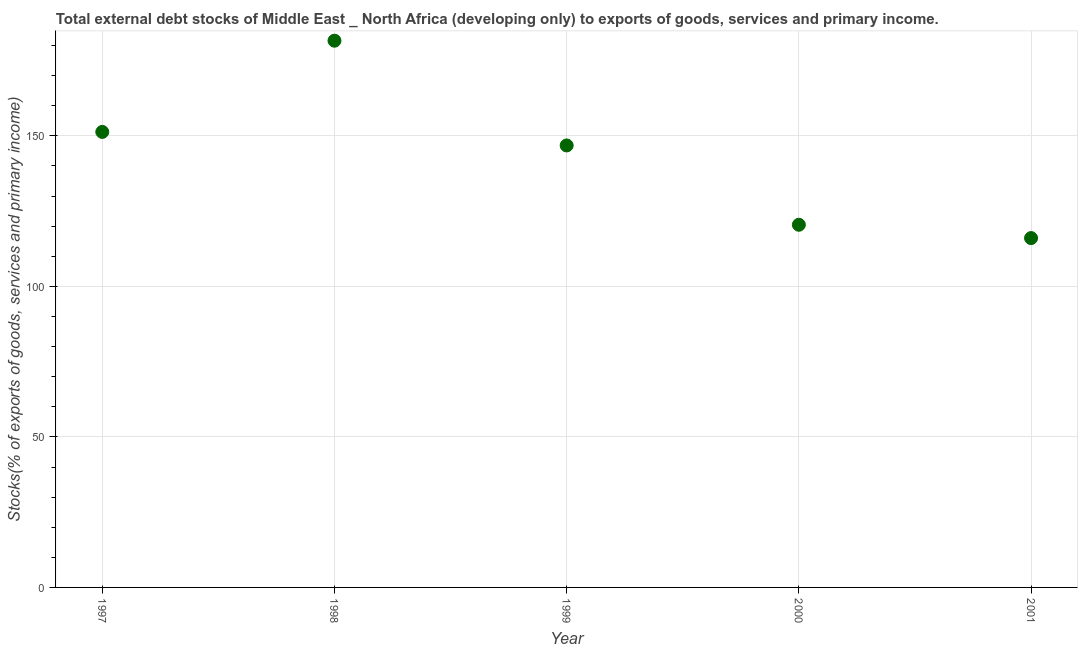What is the external debt stocks in 2001?
Keep it short and to the point. 116.04. Across all years, what is the maximum external debt stocks?
Your answer should be very brief. 181.6. Across all years, what is the minimum external debt stocks?
Your response must be concise. 116.04. In which year was the external debt stocks minimum?
Provide a short and direct response. 2001. What is the sum of the external debt stocks?
Offer a terse response. 716.22. What is the difference between the external debt stocks in 1998 and 2000?
Offer a very short reply. 61.14. What is the average external debt stocks per year?
Offer a terse response. 143.24. What is the median external debt stocks?
Ensure brevity in your answer.  146.81. What is the ratio of the external debt stocks in 1998 to that in 2001?
Your response must be concise. 1.57. Is the difference between the external debt stocks in 1997 and 1999 greater than the difference between any two years?
Offer a terse response. No. What is the difference between the highest and the second highest external debt stocks?
Your answer should be very brief. 30.3. Is the sum of the external debt stocks in 1999 and 2001 greater than the maximum external debt stocks across all years?
Ensure brevity in your answer.  Yes. What is the difference between the highest and the lowest external debt stocks?
Offer a very short reply. 65.56. How many years are there in the graph?
Your answer should be compact. 5. Does the graph contain any zero values?
Provide a short and direct response. No. What is the title of the graph?
Provide a short and direct response. Total external debt stocks of Middle East _ North Africa (developing only) to exports of goods, services and primary income. What is the label or title of the Y-axis?
Your answer should be very brief. Stocks(% of exports of goods, services and primary income). What is the Stocks(% of exports of goods, services and primary income) in 1997?
Your answer should be compact. 151.3. What is the Stocks(% of exports of goods, services and primary income) in 1998?
Ensure brevity in your answer.  181.6. What is the Stocks(% of exports of goods, services and primary income) in 1999?
Offer a terse response. 146.81. What is the Stocks(% of exports of goods, services and primary income) in 2000?
Provide a succinct answer. 120.47. What is the Stocks(% of exports of goods, services and primary income) in 2001?
Provide a succinct answer. 116.04. What is the difference between the Stocks(% of exports of goods, services and primary income) in 1997 and 1998?
Your answer should be very brief. -30.3. What is the difference between the Stocks(% of exports of goods, services and primary income) in 1997 and 1999?
Give a very brief answer. 4.5. What is the difference between the Stocks(% of exports of goods, services and primary income) in 1997 and 2000?
Keep it short and to the point. 30.84. What is the difference between the Stocks(% of exports of goods, services and primary income) in 1997 and 2001?
Your answer should be very brief. 35.26. What is the difference between the Stocks(% of exports of goods, services and primary income) in 1998 and 1999?
Provide a succinct answer. 34.8. What is the difference between the Stocks(% of exports of goods, services and primary income) in 1998 and 2000?
Your answer should be compact. 61.14. What is the difference between the Stocks(% of exports of goods, services and primary income) in 1998 and 2001?
Offer a terse response. 65.56. What is the difference between the Stocks(% of exports of goods, services and primary income) in 1999 and 2000?
Offer a terse response. 26.34. What is the difference between the Stocks(% of exports of goods, services and primary income) in 1999 and 2001?
Make the answer very short. 30.77. What is the difference between the Stocks(% of exports of goods, services and primary income) in 2000 and 2001?
Keep it short and to the point. 4.43. What is the ratio of the Stocks(% of exports of goods, services and primary income) in 1997 to that in 1998?
Ensure brevity in your answer.  0.83. What is the ratio of the Stocks(% of exports of goods, services and primary income) in 1997 to that in 1999?
Your answer should be very brief. 1.03. What is the ratio of the Stocks(% of exports of goods, services and primary income) in 1997 to that in 2000?
Offer a terse response. 1.26. What is the ratio of the Stocks(% of exports of goods, services and primary income) in 1997 to that in 2001?
Offer a terse response. 1.3. What is the ratio of the Stocks(% of exports of goods, services and primary income) in 1998 to that in 1999?
Make the answer very short. 1.24. What is the ratio of the Stocks(% of exports of goods, services and primary income) in 1998 to that in 2000?
Ensure brevity in your answer.  1.51. What is the ratio of the Stocks(% of exports of goods, services and primary income) in 1998 to that in 2001?
Offer a very short reply. 1.56. What is the ratio of the Stocks(% of exports of goods, services and primary income) in 1999 to that in 2000?
Ensure brevity in your answer.  1.22. What is the ratio of the Stocks(% of exports of goods, services and primary income) in 1999 to that in 2001?
Your answer should be very brief. 1.26. What is the ratio of the Stocks(% of exports of goods, services and primary income) in 2000 to that in 2001?
Your answer should be compact. 1.04. 